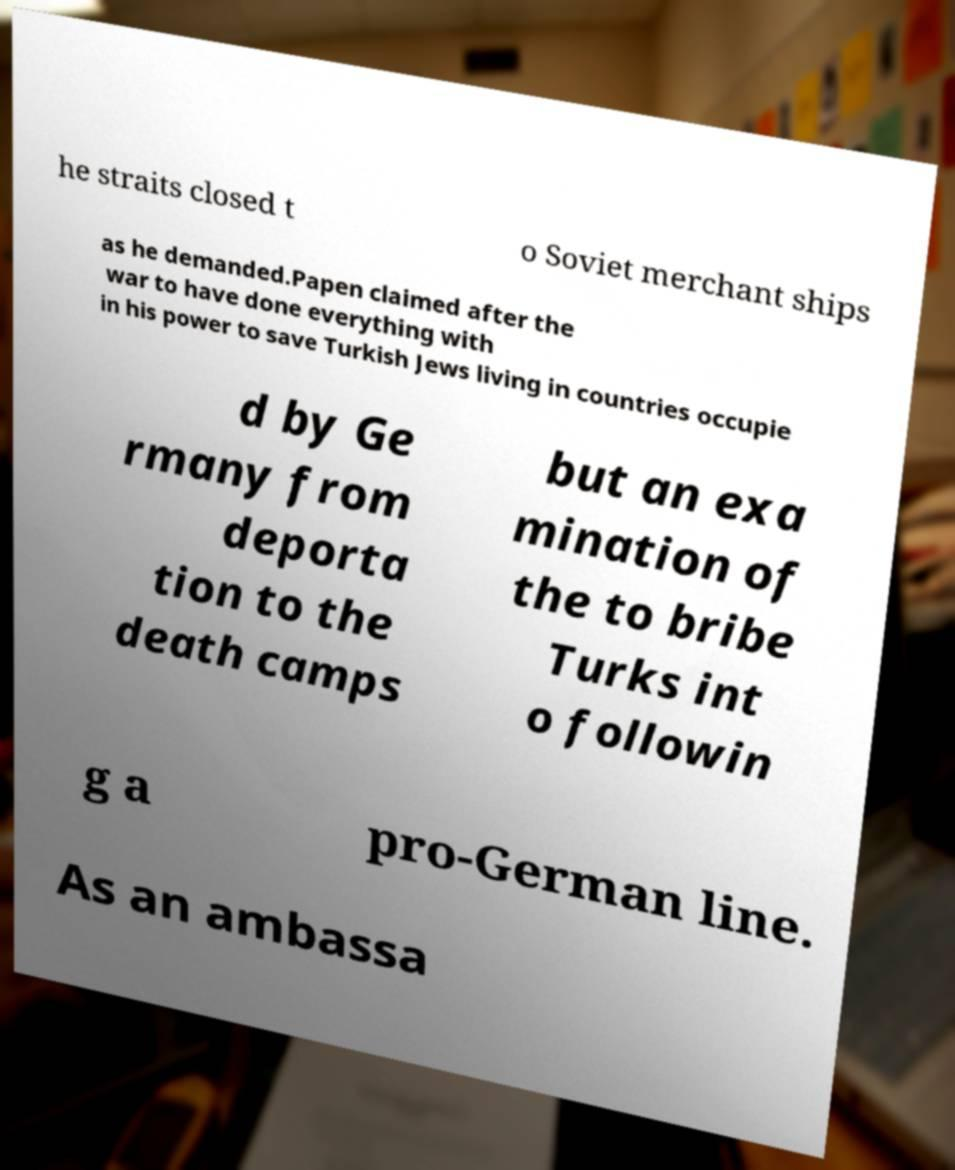For documentation purposes, I need the text within this image transcribed. Could you provide that? he straits closed t o Soviet merchant ships as he demanded.Papen claimed after the war to have done everything with in his power to save Turkish Jews living in countries occupie d by Ge rmany from deporta tion to the death camps but an exa mination of the to bribe Turks int o followin g a pro-German line. As an ambassa 